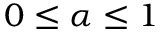Convert formula to latex. <formula><loc_0><loc_0><loc_500><loc_500>0 \leq \alpha \leq 1</formula> 